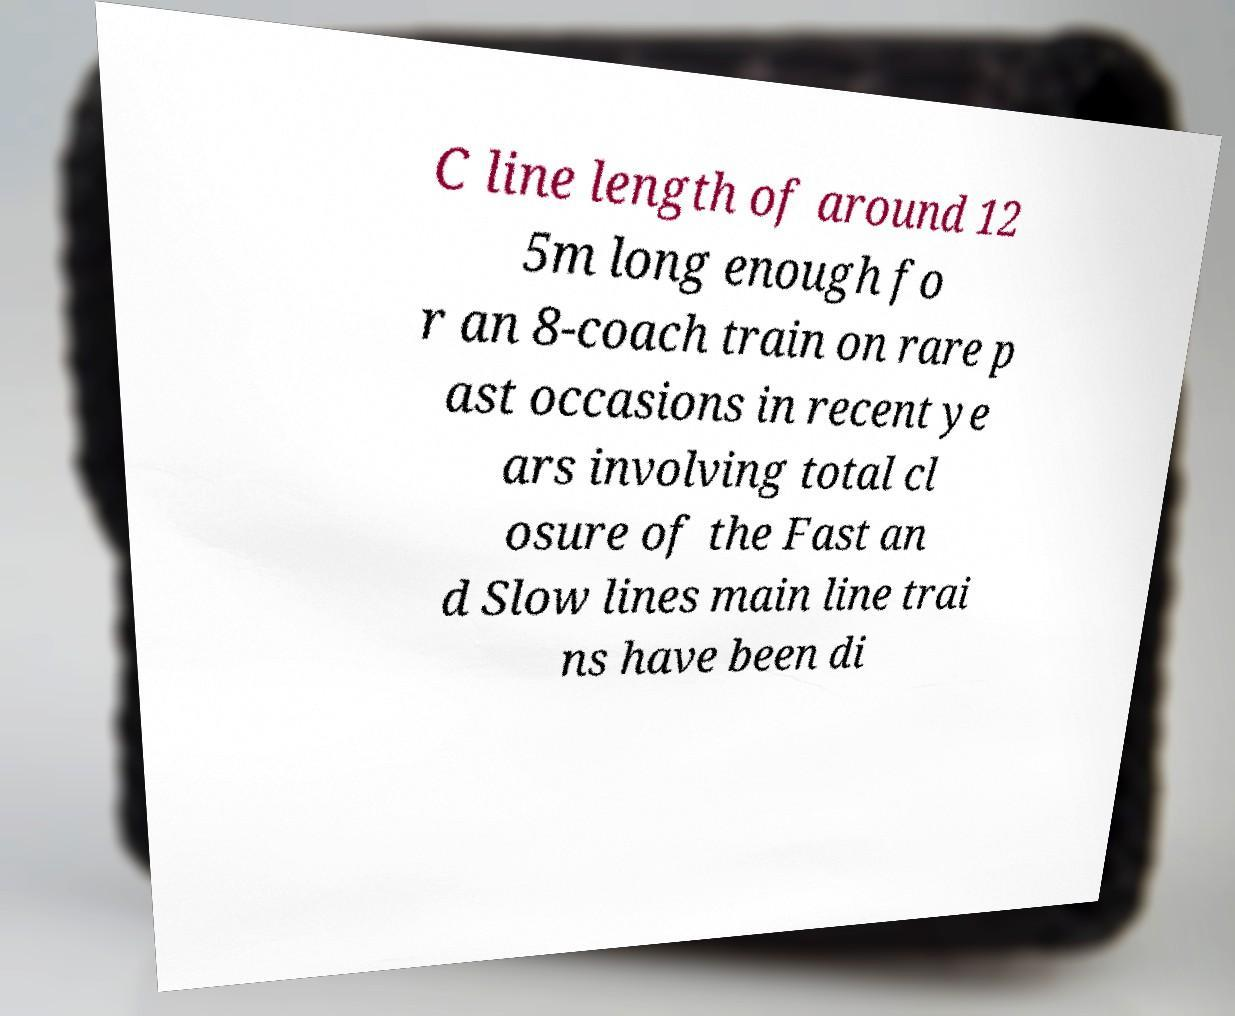For documentation purposes, I need the text within this image transcribed. Could you provide that? C line length of around 12 5m long enough fo r an 8-coach train on rare p ast occasions in recent ye ars involving total cl osure of the Fast an d Slow lines main line trai ns have been di 